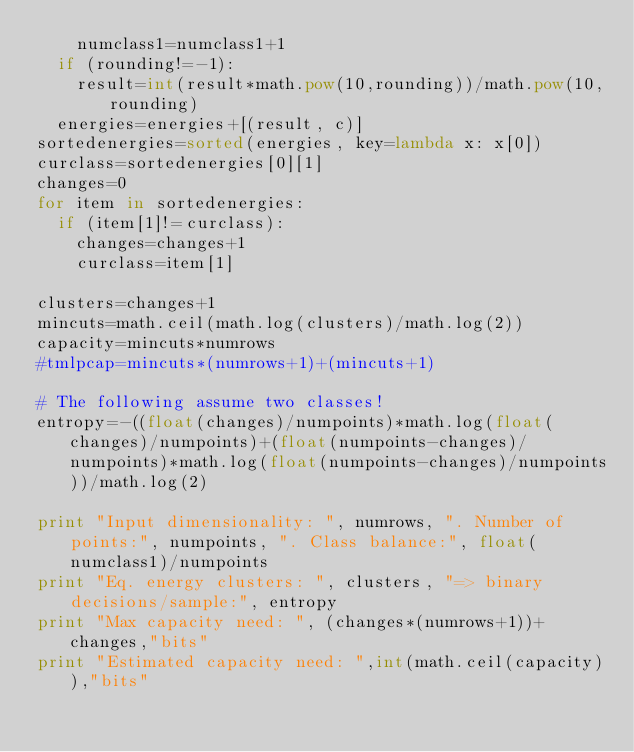Convert code to text. <code><loc_0><loc_0><loc_500><loc_500><_Python_>		numclass1=numclass1+1
	if (rounding!=-1):
		result=int(result*math.pow(10,rounding))/math.pow(10,rounding)
	energies=energies+[(result, c)]
sortedenergies=sorted(energies, key=lambda x: x[0])
curclass=sortedenergies[0][1]
changes=0
for item in sortedenergies:
	if (item[1]!=curclass):
		changes=changes+1
		curclass=item[1]

clusters=changes+1
mincuts=math.ceil(math.log(clusters)/math.log(2))
capacity=mincuts*numrows
#tmlpcap=mincuts*(numrows+1)+(mincuts+1)

# The following assume two classes!
entropy=-((float(changes)/numpoints)*math.log(float(changes)/numpoints)+(float(numpoints-changes)/numpoints)*math.log(float(numpoints-changes)/numpoints))/math.log(2)

print "Input dimensionality: ", numrows, ". Number of points:", numpoints, ". Class balance:", float(numclass1)/numpoints 
print "Eq. energy clusters: ", clusters, "=> binary decisions/sample:", entropy
print "Max capacity need: ", (changes*(numrows+1))+changes,"bits"
print "Estimated capacity need: ",int(math.ceil(capacity)),"bits"

</code> 